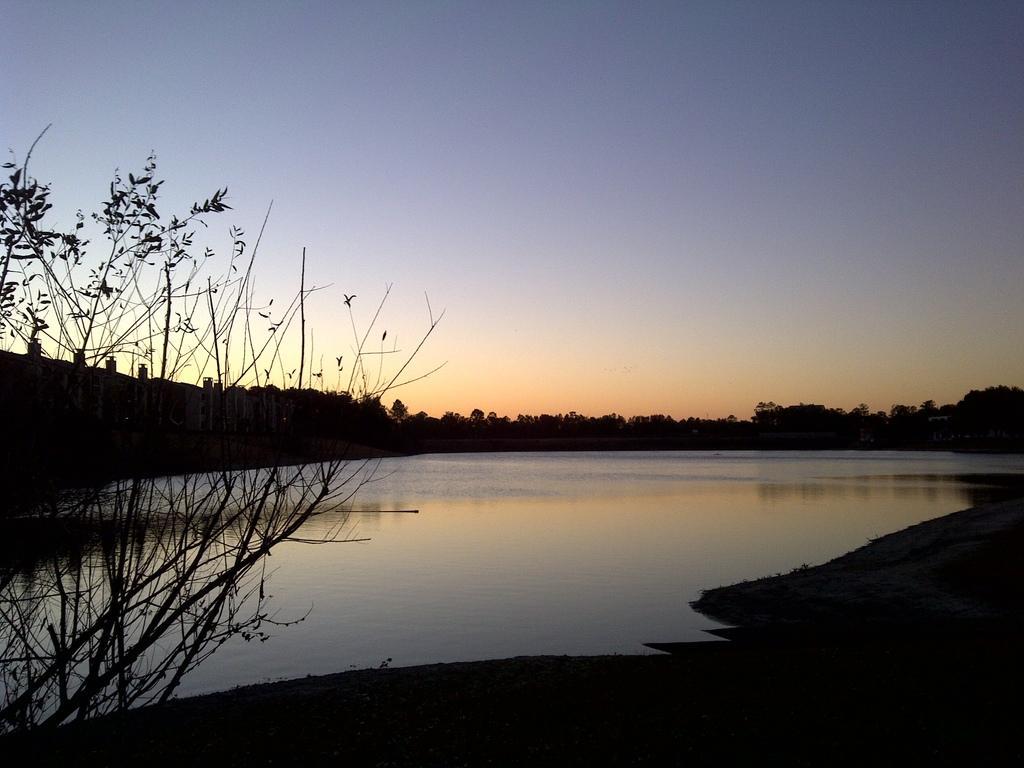Can you describe this image briefly? In this picture we can see a lake and few trees. 